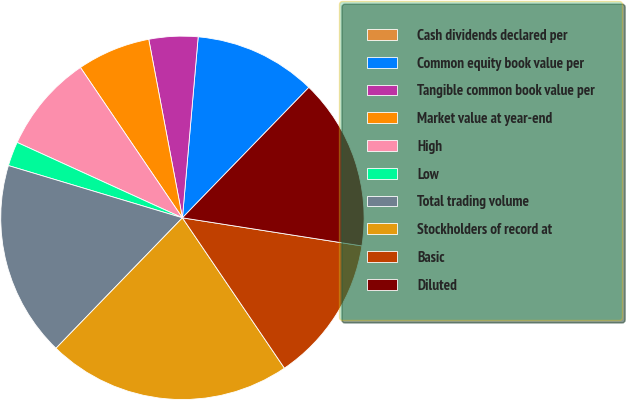Convert chart to OTSL. <chart><loc_0><loc_0><loc_500><loc_500><pie_chart><fcel>Cash dividends declared per<fcel>Common equity book value per<fcel>Tangible common book value per<fcel>Market value at year-end<fcel>High<fcel>Low<fcel>Total trading volume<fcel>Stockholders of record at<fcel>Basic<fcel>Diluted<nl><fcel>0.0%<fcel>10.87%<fcel>4.35%<fcel>6.52%<fcel>8.7%<fcel>2.17%<fcel>17.39%<fcel>21.74%<fcel>13.04%<fcel>15.22%<nl></chart> 